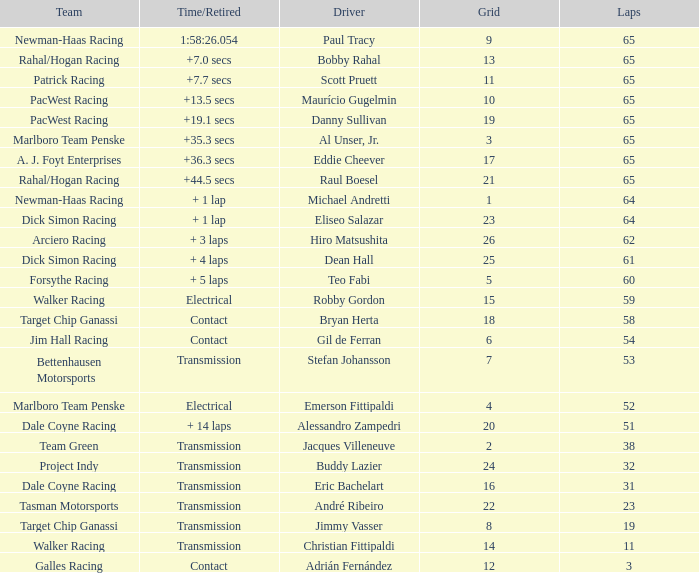What was the highest grid for a time/retired of +19.1 secs? 19.0. 